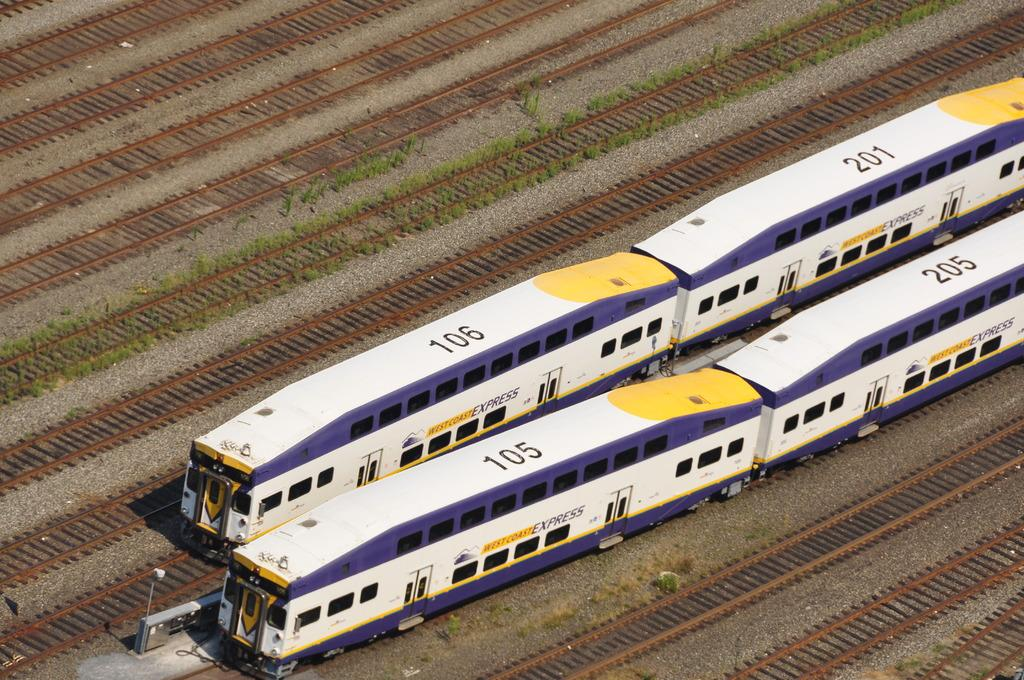How many trains can be seen in the image? There are two trains in the image. What colors are the trains? The trains are white and purple in color. What are the trains doing in the image? The trains are moving on railway tracks. How many railway tracks are visible in the image? There are multiple railway tracks visible. What type of vegetation is present on the ground? There are plants on the ground. Can you see the porter's feet in the image? There is no porter or feet visible in the image; it only shows two trains moving on railway tracks. 